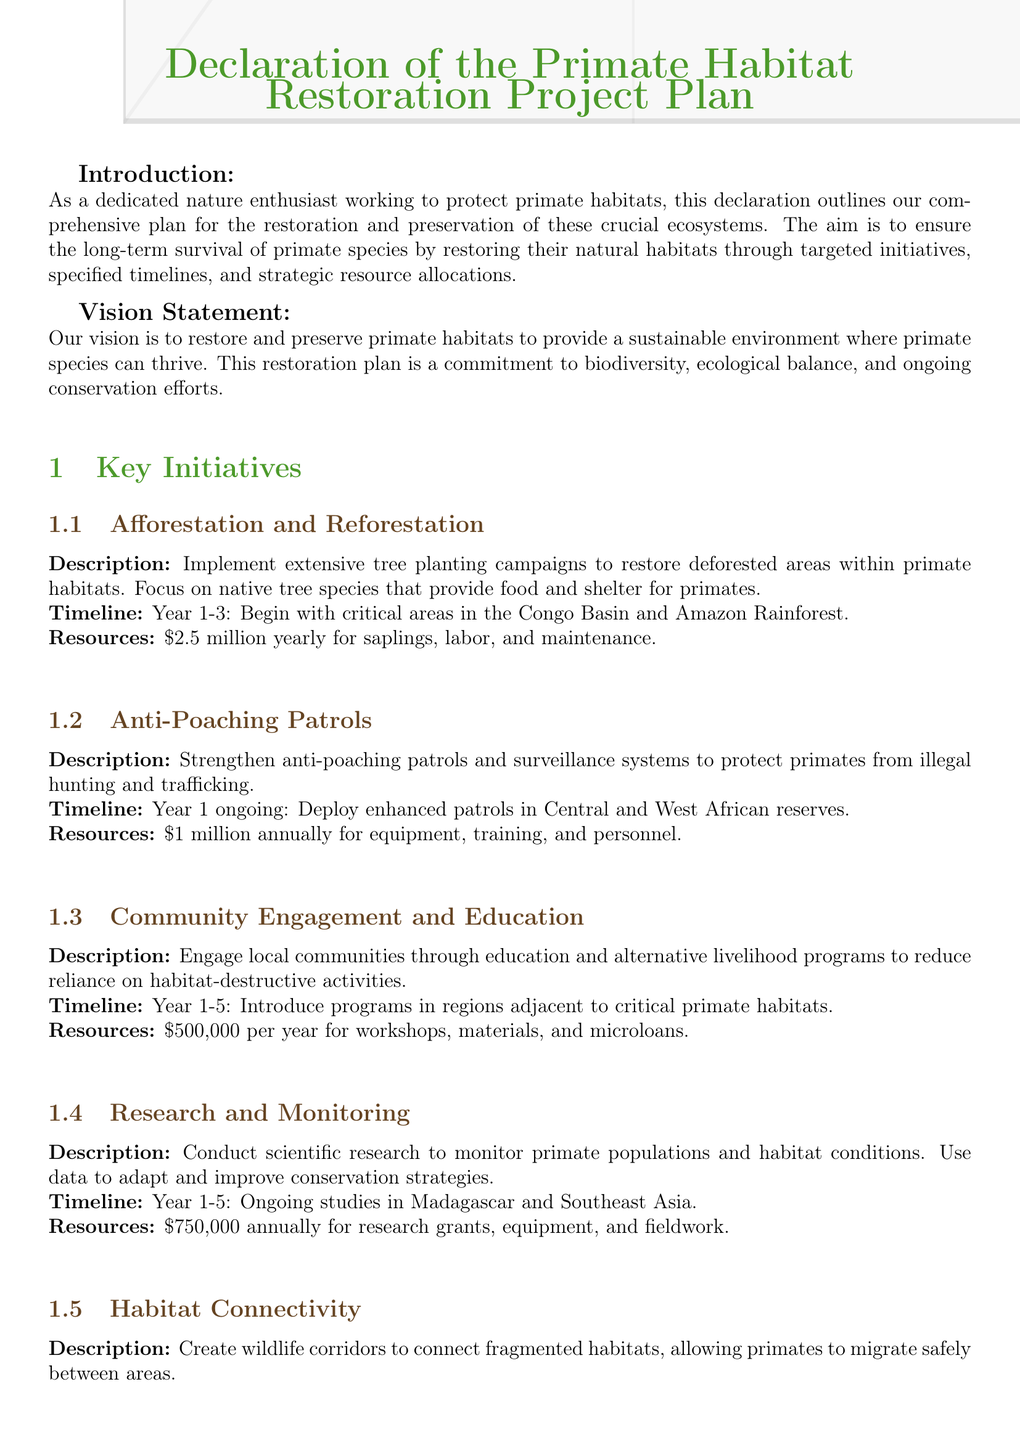what is the budget for afforestation and reforestation? The budget allocated for afforestation and reforestation is detailed in the plan as $2.5 million yearly for saplings, labor, and maintenance.
Answer: $2.5 million yearly what is the duration of the Community Engagement and Education initiative? The initiative spans from Year 1 to Year 5, as stated in the document.
Answer: Year 1-5 how much is allocated for anti-poaching patrols annually? The document specifies that anti-poaching patrols will receive $1 million annually for equipment, training, and personnel.
Answer: $1 million annually which areas will benefit from habitat connectivity initiatives? The specific areas mentioned for habitat connectivity initiatives are Borneo and the Atlantic Forest in the document.
Answer: Borneo and the Atlantic Forest how many years will research and monitoring be conducted? Research and monitoring will be conducted over a period of five years according to the timeline provided.
Answer: 5 years what is the primary goal of the restoration project? The primary goal of the restoration project is outlined in the vision statement as restoring and preserving primate habitats for their survival.
Answer: Restoring and preserving primate habitats what is the total annual budget for habitat restoration initiatives? The total annual budget can be calculated by adding the yearly budgets for each initiative outlined in the document.
Answer: $5.95 million what types of education programs are included in the initiative? The education programs are alternative livelihood programs aimed at reducing reliance on habitat-destructive activities.
Answer: Alternative livelihood programs what is the focus of the reforestation initiative? The focus of the reforestation initiative is on native tree species that provide food and shelter for primates.
Answer: Native tree species 